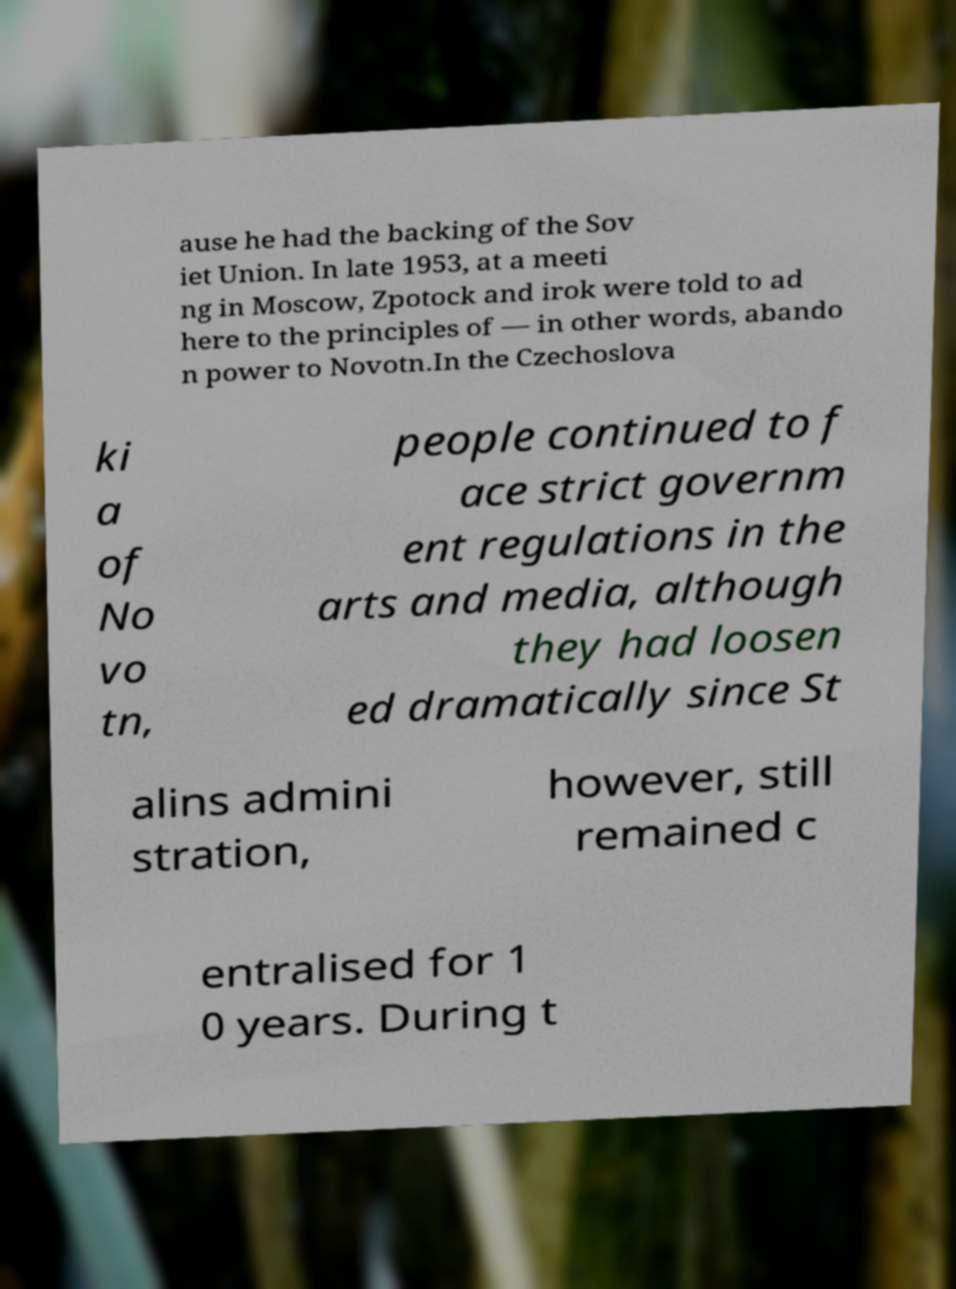Please identify and transcribe the text found in this image. ause he had the backing of the Sov iet Union. In late 1953, at a meeti ng in Moscow, Zpotock and irok were told to ad here to the principles of — in other words, abando n power to Novotn.In the Czechoslova ki a of No vo tn, people continued to f ace strict governm ent regulations in the arts and media, although they had loosen ed dramatically since St alins admini stration, however, still remained c entralised for 1 0 years. During t 